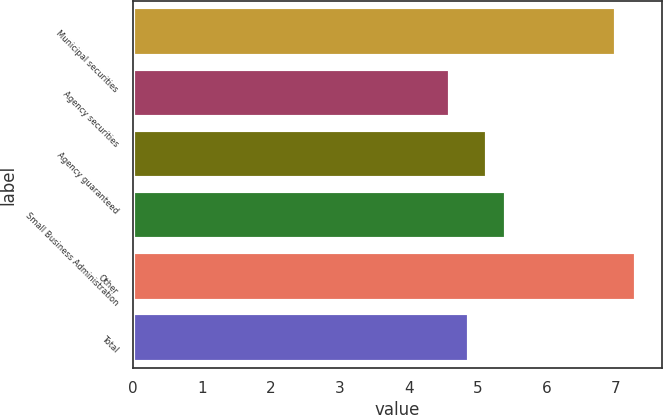<chart> <loc_0><loc_0><loc_500><loc_500><bar_chart><fcel>Municipal securities<fcel>Agency securities<fcel>Agency guaranteed<fcel>Small Business Administration<fcel>Other<fcel>Total<nl><fcel>7<fcel>4.6<fcel>5.14<fcel>5.41<fcel>7.3<fcel>4.87<nl></chart> 